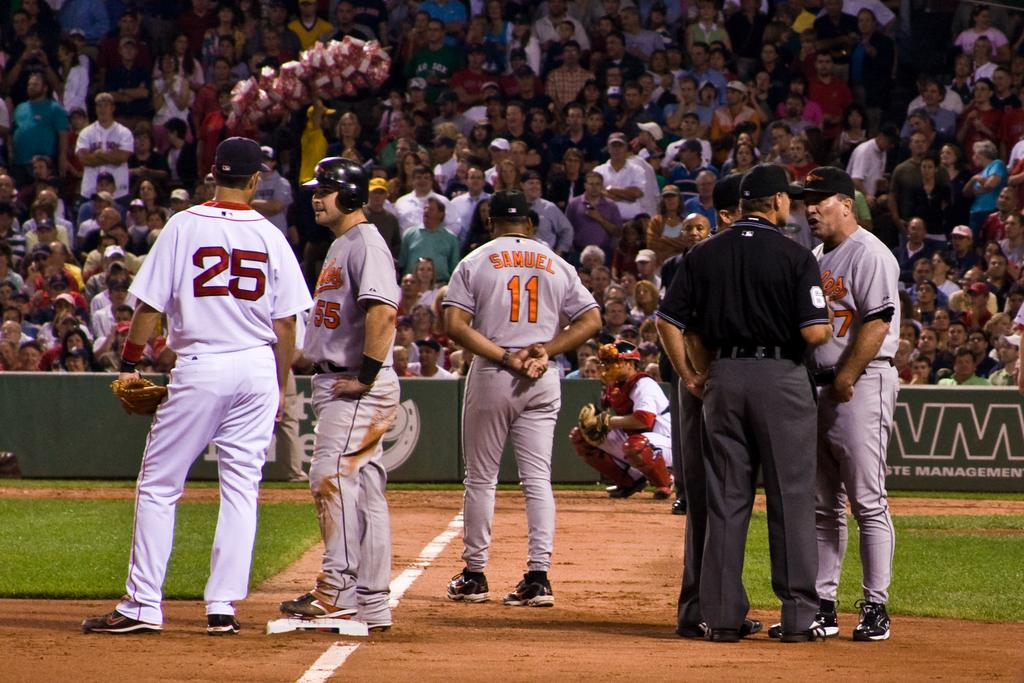<image>
Present a compact description of the photo's key features. A baseball player with the name Samuel printed on the back of his jersey stands with other players. 